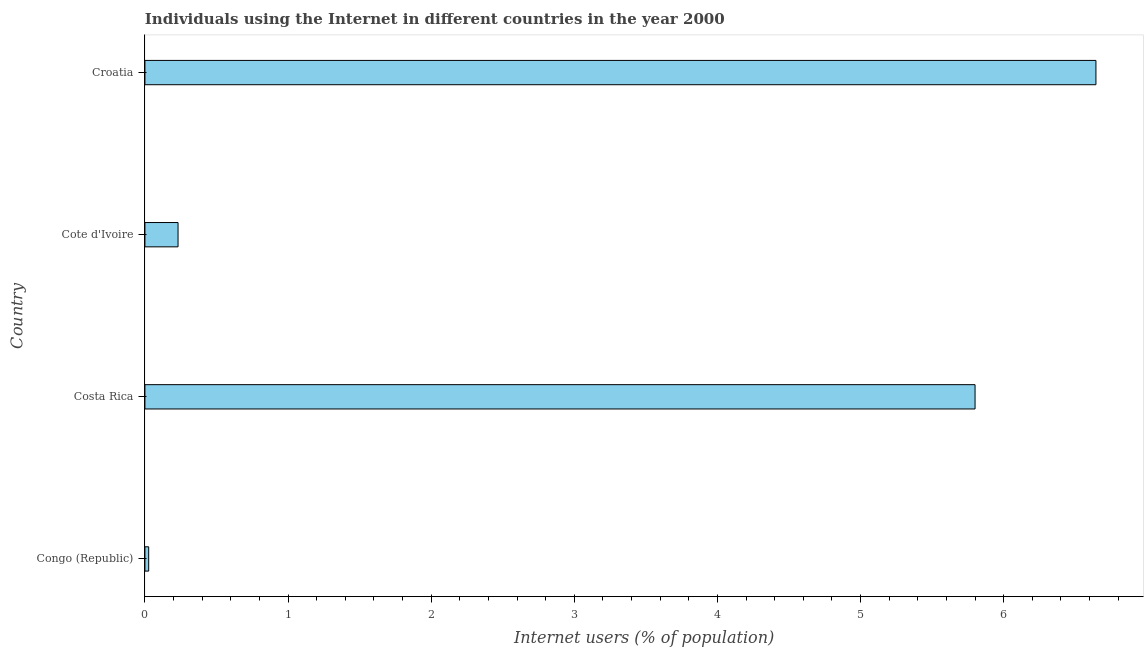Does the graph contain any zero values?
Provide a short and direct response. No. What is the title of the graph?
Give a very brief answer. Individuals using the Internet in different countries in the year 2000. What is the label or title of the X-axis?
Offer a terse response. Internet users (% of population). What is the number of internet users in Costa Rica?
Offer a very short reply. 5.8. Across all countries, what is the maximum number of internet users?
Offer a very short reply. 6.64. Across all countries, what is the minimum number of internet users?
Offer a very short reply. 0.03. In which country was the number of internet users maximum?
Give a very brief answer. Croatia. In which country was the number of internet users minimum?
Offer a very short reply. Congo (Republic). What is the sum of the number of internet users?
Keep it short and to the point. 12.7. What is the difference between the number of internet users in Costa Rica and Cote d'Ivoire?
Make the answer very short. 5.57. What is the average number of internet users per country?
Your answer should be very brief. 3.18. What is the median number of internet users?
Your response must be concise. 3.02. In how many countries, is the number of internet users greater than 3.6 %?
Provide a succinct answer. 2. What is the ratio of the number of internet users in Costa Rica to that in Croatia?
Offer a terse response. 0.87. Is the number of internet users in Congo (Republic) less than that in Croatia?
Keep it short and to the point. Yes. What is the difference between the highest and the second highest number of internet users?
Make the answer very short. 0.84. Is the sum of the number of internet users in Congo (Republic) and Cote d'Ivoire greater than the maximum number of internet users across all countries?
Your response must be concise. No. What is the difference between the highest and the lowest number of internet users?
Provide a short and direct response. 6.62. In how many countries, is the number of internet users greater than the average number of internet users taken over all countries?
Offer a very short reply. 2. How many bars are there?
Offer a very short reply. 4. Are all the bars in the graph horizontal?
Provide a succinct answer. Yes. What is the difference between two consecutive major ticks on the X-axis?
Your answer should be very brief. 1. What is the Internet users (% of population) of Congo (Republic)?
Give a very brief answer. 0.03. What is the Internet users (% of population) in Costa Rica?
Keep it short and to the point. 5.8. What is the Internet users (% of population) in Cote d'Ivoire?
Ensure brevity in your answer.  0.23. What is the Internet users (% of population) of Croatia?
Offer a very short reply. 6.64. What is the difference between the Internet users (% of population) in Congo (Republic) and Costa Rica?
Provide a short and direct response. -5.77. What is the difference between the Internet users (% of population) in Congo (Republic) and Cote d'Ivoire?
Offer a very short reply. -0.21. What is the difference between the Internet users (% of population) in Congo (Republic) and Croatia?
Provide a short and direct response. -6.62. What is the difference between the Internet users (% of population) in Costa Rica and Cote d'Ivoire?
Keep it short and to the point. 5.57. What is the difference between the Internet users (% of population) in Costa Rica and Croatia?
Give a very brief answer. -0.84. What is the difference between the Internet users (% of population) in Cote d'Ivoire and Croatia?
Keep it short and to the point. -6.41. What is the ratio of the Internet users (% of population) in Congo (Republic) to that in Costa Rica?
Your answer should be very brief. 0.01. What is the ratio of the Internet users (% of population) in Congo (Republic) to that in Cote d'Ivoire?
Offer a very short reply. 0.11. What is the ratio of the Internet users (% of population) in Congo (Republic) to that in Croatia?
Provide a succinct answer. 0. What is the ratio of the Internet users (% of population) in Costa Rica to that in Cote d'Ivoire?
Offer a terse response. 25.06. What is the ratio of the Internet users (% of population) in Costa Rica to that in Croatia?
Give a very brief answer. 0.87. What is the ratio of the Internet users (% of population) in Cote d'Ivoire to that in Croatia?
Give a very brief answer. 0.04. 